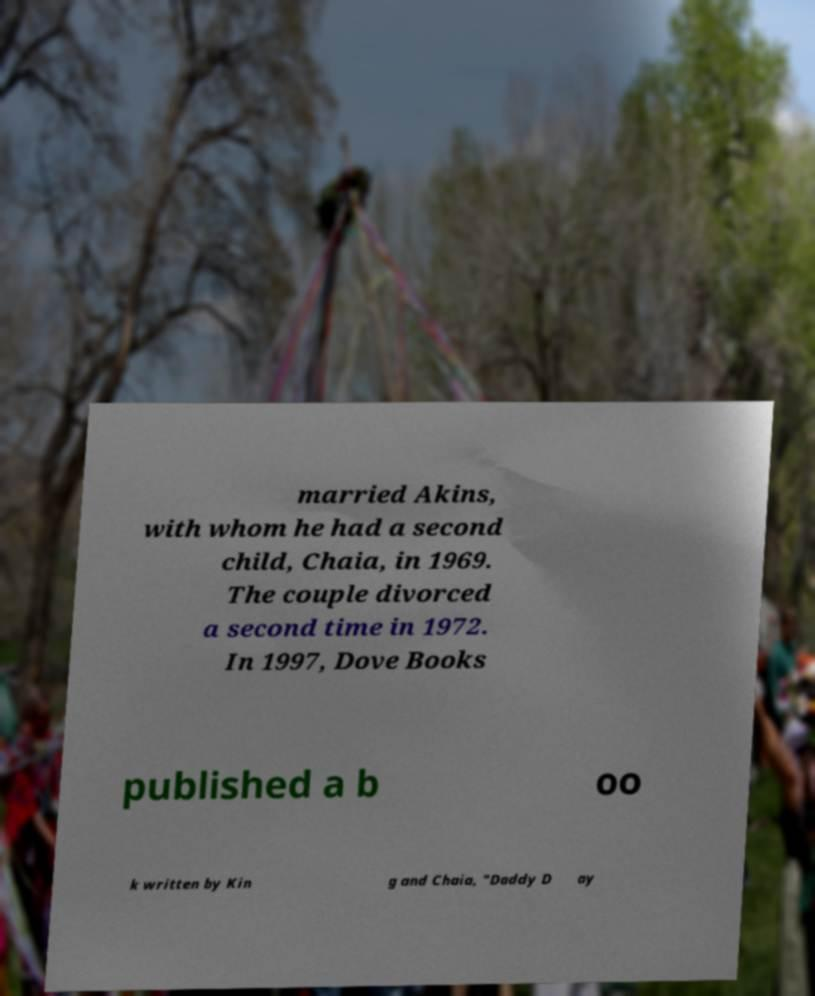There's text embedded in this image that I need extracted. Can you transcribe it verbatim? married Akins, with whom he had a second child, Chaia, in 1969. The couple divorced a second time in 1972. In 1997, Dove Books published a b oo k written by Kin g and Chaia, "Daddy D ay 